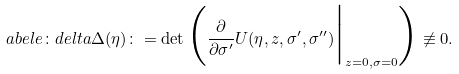Convert formula to latex. <formula><loc_0><loc_0><loc_500><loc_500>\L a b e l { e \colon d e l t a } \Delta ( \eta ) \colon = \det \Big ( \frac { \partial } { \partial \sigma ^ { \prime } } U ( \eta , z , \sigma ^ { \prime } , \sigma ^ { \prime \prime } ) \Big | _ { z = 0 , \sigma = 0 } \Big ) \not \equiv 0 .</formula> 